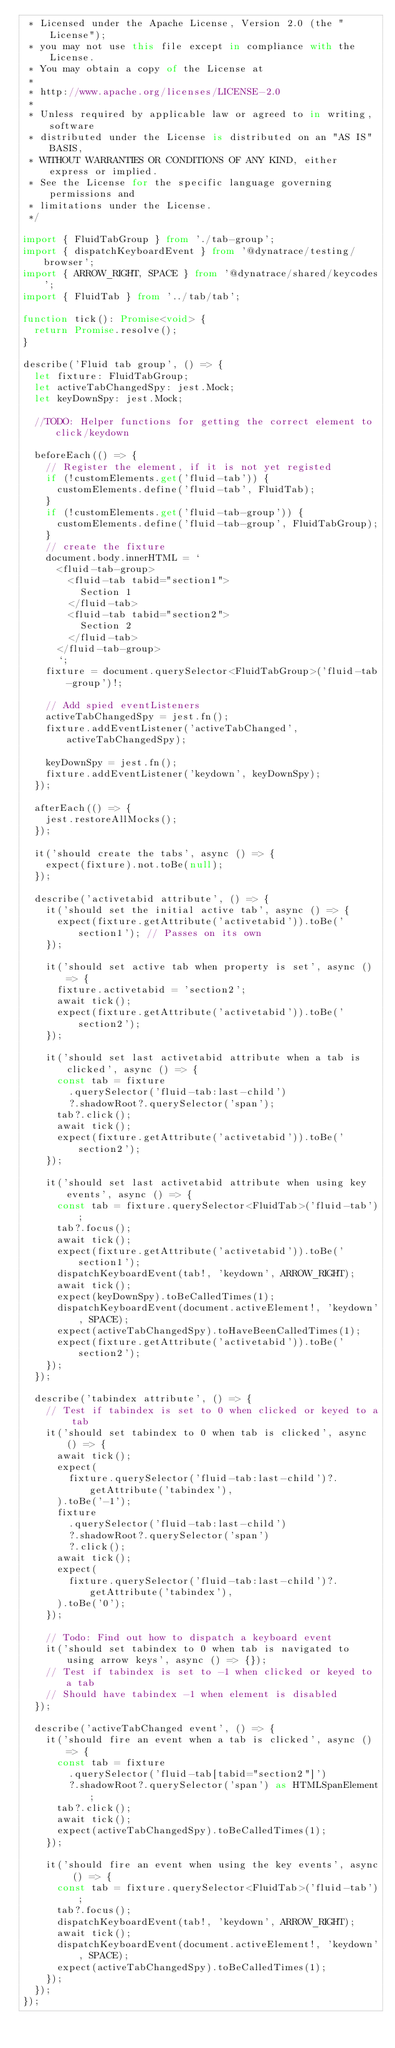Convert code to text. <code><loc_0><loc_0><loc_500><loc_500><_TypeScript_> * Licensed under the Apache License, Version 2.0 (the "License");
 * you may not use this file except in compliance with the License.
 * You may obtain a copy of the License at
 *
 * http://www.apache.org/licenses/LICENSE-2.0
 *
 * Unless required by applicable law or agreed to in writing, software
 * distributed under the License is distributed on an "AS IS" BASIS,
 * WITHOUT WARRANTIES OR CONDITIONS OF ANY KIND, either express or implied.
 * See the License for the specific language governing permissions and
 * limitations under the License.
 */

import { FluidTabGroup } from './tab-group';
import { dispatchKeyboardEvent } from '@dynatrace/testing/browser';
import { ARROW_RIGHT, SPACE } from '@dynatrace/shared/keycodes';
import { FluidTab } from '../tab/tab';

function tick(): Promise<void> {
  return Promise.resolve();
}

describe('Fluid tab group', () => {
  let fixture: FluidTabGroup;
  let activeTabChangedSpy: jest.Mock;
  let keyDownSpy: jest.Mock;

  //TODO: Helper functions for getting the correct element to click/keydown

  beforeEach(() => {
    // Register the element, if it is not yet registed
    if (!customElements.get('fluid-tab')) {
      customElements.define('fluid-tab', FluidTab);
    }
    if (!customElements.get('fluid-tab-group')) {
      customElements.define('fluid-tab-group', FluidTabGroup);
    }
    // create the fixture
    document.body.innerHTML = `
      <fluid-tab-group>
        <fluid-tab tabid="section1">
          Section 1
        </fluid-tab>
        <fluid-tab tabid="section2">
          Section 2
        </fluid-tab>
      </fluid-tab-group>
      `;
    fixture = document.querySelector<FluidTabGroup>('fluid-tab-group')!;

    // Add spied eventListeners
    activeTabChangedSpy = jest.fn();
    fixture.addEventListener('activeTabChanged', activeTabChangedSpy);

    keyDownSpy = jest.fn();
    fixture.addEventListener('keydown', keyDownSpy);
  });

  afterEach(() => {
    jest.restoreAllMocks();
  });

  it('should create the tabs', async () => {
    expect(fixture).not.toBe(null);
  });

  describe('activetabid attribute', () => {
    it('should set the initial active tab', async () => {
      expect(fixture.getAttribute('activetabid')).toBe('section1'); // Passes on its own
    });

    it('should set active tab when property is set', async () => {
      fixture.activetabid = 'section2';
      await tick();
      expect(fixture.getAttribute('activetabid')).toBe('section2');
    });

    it('should set last activetabid attribute when a tab is clicked', async () => {
      const tab = fixture
        .querySelector('fluid-tab:last-child')
        ?.shadowRoot?.querySelector('span');
      tab?.click();
      await tick();
      expect(fixture.getAttribute('activetabid')).toBe('section2');
    });

    it('should set last activetabid attribute when using key events', async () => {
      const tab = fixture.querySelector<FluidTab>('fluid-tab');
      tab?.focus();
      await tick();
      expect(fixture.getAttribute('activetabid')).toBe('section1');
      dispatchKeyboardEvent(tab!, 'keydown', ARROW_RIGHT);
      await tick();
      expect(keyDownSpy).toBeCalledTimes(1);
      dispatchKeyboardEvent(document.activeElement!, 'keydown', SPACE);
      expect(activeTabChangedSpy).toHaveBeenCalledTimes(1);
      expect(fixture.getAttribute('activetabid')).toBe('section2');
    });
  });

  describe('tabindex attribute', () => {
    // Test if tabindex is set to 0 when clicked or keyed to a tab
    it('should set tabindex to 0 when tab is clicked', async () => {
      await tick();
      expect(
        fixture.querySelector('fluid-tab:last-child')?.getAttribute('tabindex'),
      ).toBe('-1');
      fixture
        .querySelector('fluid-tab:last-child')
        ?.shadowRoot?.querySelector('span')
        ?.click();
      await tick();
      expect(
        fixture.querySelector('fluid-tab:last-child')?.getAttribute('tabindex'),
      ).toBe('0');
    });

    // Todo: Find out how to dispatch a keyboard event
    it('should set tabindex to 0 when tab is navigated to using arrow keys', async () => {});
    // Test if tabindex is set to -1 when clicked or keyed to a tab
    // Should have tabindex -1 when element is disabled
  });

  describe('activeTabChanged event', () => {
    it('should fire an event when a tab is clicked', async () => {
      const tab = fixture
        .querySelector('fluid-tab[tabid="section2"]')
        ?.shadowRoot?.querySelector('span') as HTMLSpanElement;
      tab?.click();
      await tick();
      expect(activeTabChangedSpy).toBeCalledTimes(1);
    });

    it('should fire an event when using the key events', async () => {
      const tab = fixture.querySelector<FluidTab>('fluid-tab');
      tab?.focus();
      dispatchKeyboardEvent(tab!, 'keydown', ARROW_RIGHT);
      await tick();
      dispatchKeyboardEvent(document.activeElement!, 'keydown', SPACE);
      expect(activeTabChangedSpy).toBeCalledTimes(1);
    });
  });
});
</code> 